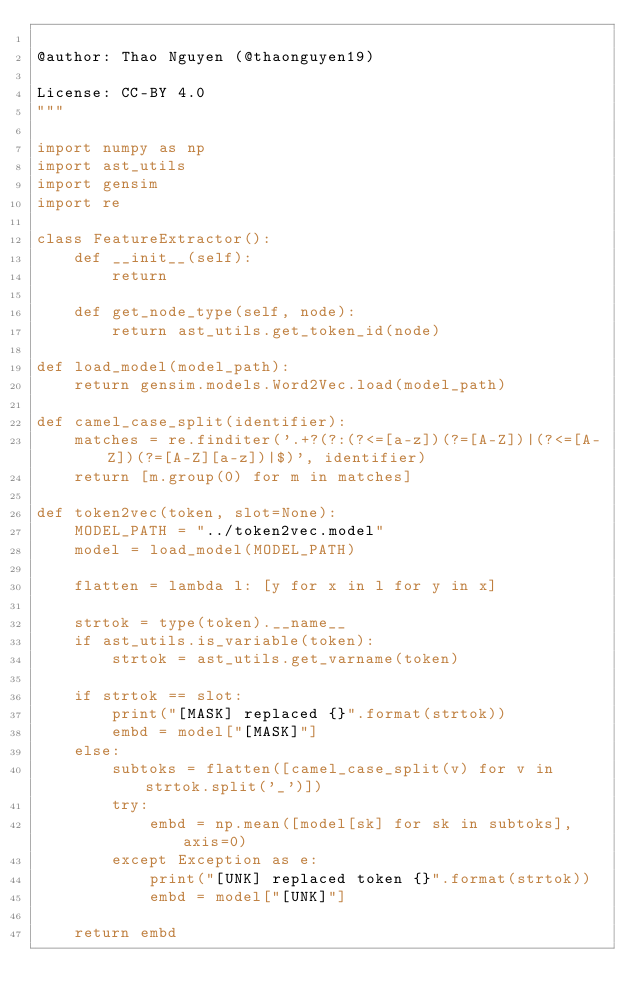Convert code to text. <code><loc_0><loc_0><loc_500><loc_500><_Python_>
@author: Thao Nguyen (@thaonguyen19)

License: CC-BY 4.0
"""

import numpy as np
import ast_utils
import gensim
import re

class FeatureExtractor():
    def __init__(self):
        return

    def get_node_type(self, node):
        return ast_utils.get_token_id(node)

def load_model(model_path):
    return gensim.models.Word2Vec.load(model_path)

def camel_case_split(identifier):
    matches = re.finditer('.+?(?:(?<=[a-z])(?=[A-Z])|(?<=[A-Z])(?=[A-Z][a-z])|$)', identifier)
    return [m.group(0) for m in matches]

def token2vec(token, slot=None):
    MODEL_PATH = "../token2vec.model"
    model = load_model(MODEL_PATH)

    flatten = lambda l: [y for x in l for y in x]

    strtok = type(token).__name__
    if ast_utils.is_variable(token):
        strtok = ast_utils.get_varname(token)

    if strtok == slot:
        print("[MASK] replaced {}".format(strtok))
        embd = model["[MASK]"]
    else:
        subtoks = flatten([camel_case_split(v) for v in strtok.split('_')])
        try:
            embd = np.mean([model[sk] for sk in subtoks], axis=0)
        except Exception as e:
            print("[UNK] replaced token {}".format(strtok))
            embd = model["[UNK]"]

    return embd
</code> 